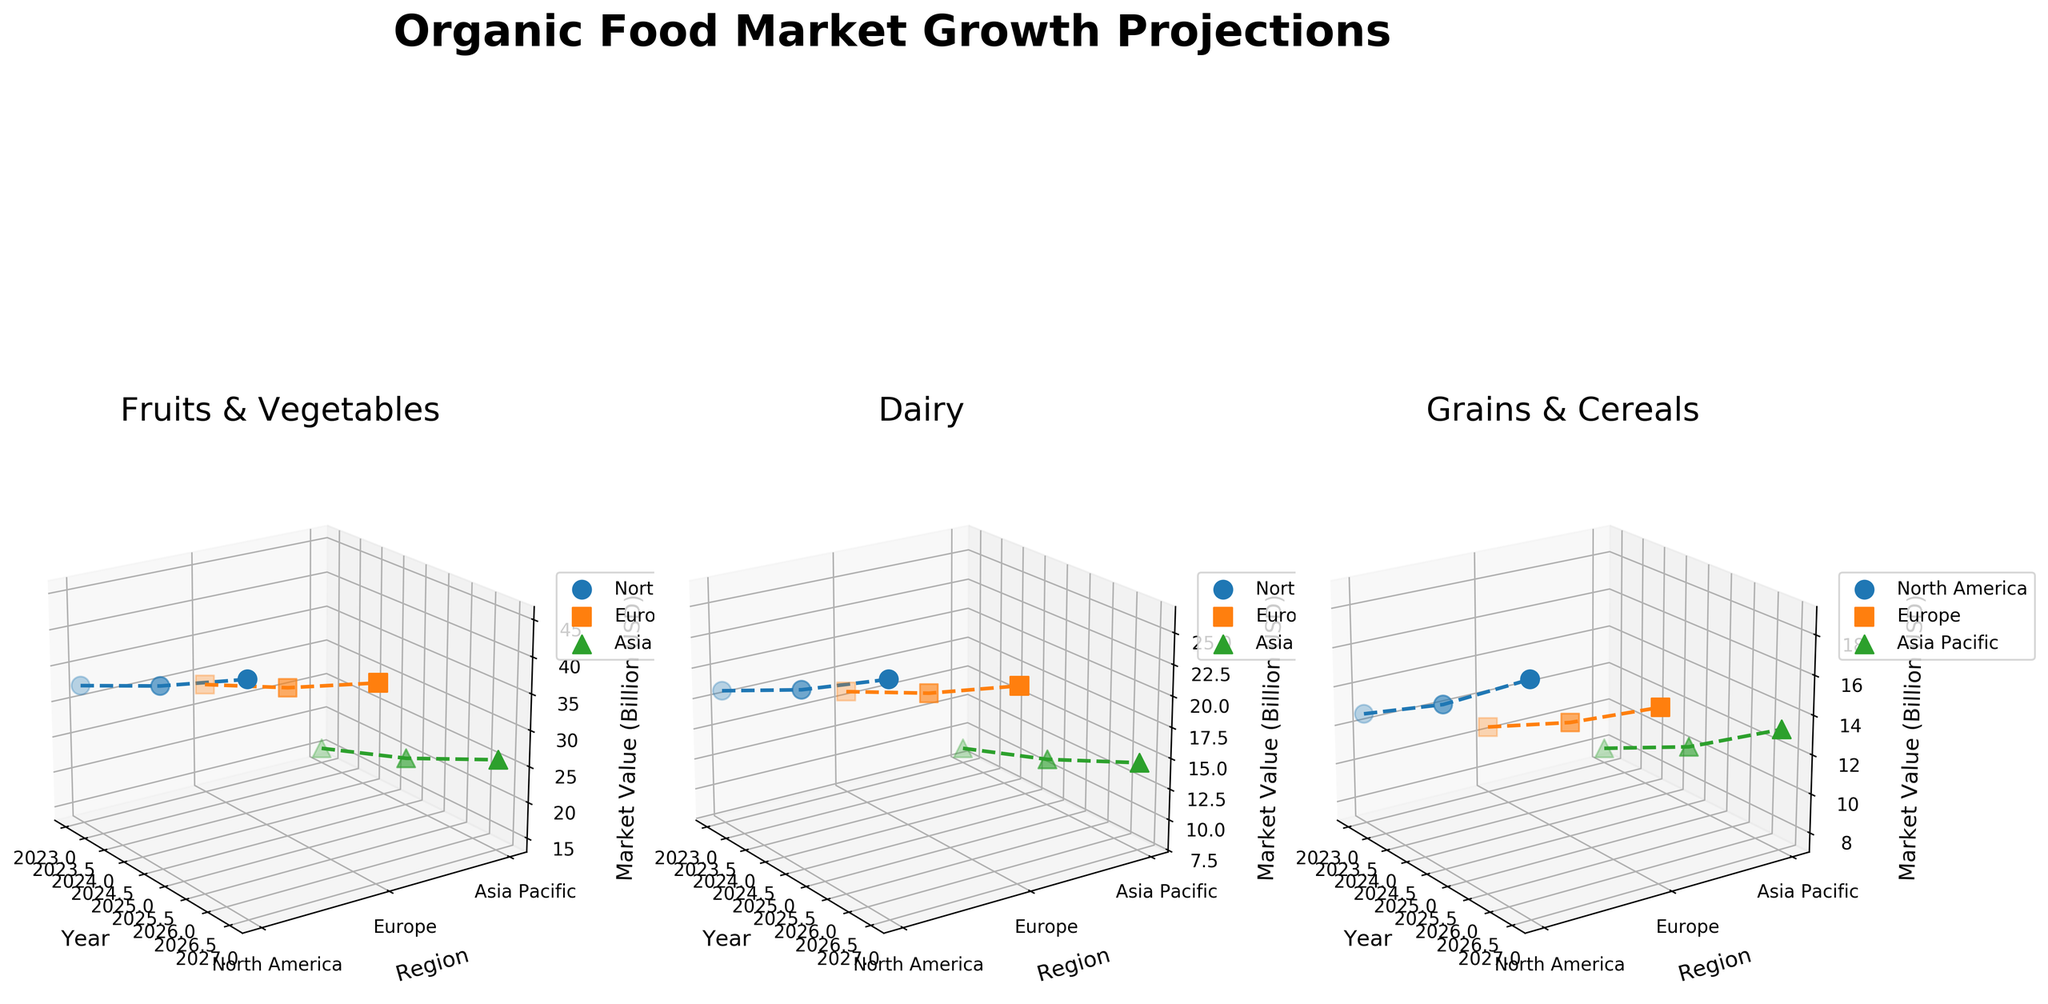What's the title of the figure? The title of the figure is located at the top center and can be directly read.
Answer: Organic Food Market Growth Projections How many regions are represented in the figure? The figure has three subplots, each plotting data for regions. The regions are distinguished by color and marker style. Each subplot has three different colors and markers, indicating three regions.
Answer: 3 Which category has the highest market value in North America in 2027? Look at the subplot for each category and identify the highest point on the market value axis (z-axis) for North America in 2027.
Answer: Fruits & Vegetables What is the trend of the market value for Dairy in Europe from 2023 to 2027? Locate the subplot for Dairy and examine the plotted lines for Europe (orange squares). From 2023 to 2027, observe the change in the market value along the z-axis.
Answer: Increasing Compare the market value of Grains & Cereals in Asia Pacific between 2023 and 2025. How much did it increase? In the subplot for Grains & Cereals, identify the z-axis values for Asia Pacific (green triangles) for the years 2023 and 2025. Calculate the difference between these values.
Answer: 2.3 Billion USD Which region shows the fastest growth in market value for Fruits & Vegetables from 2023 to 2027? In the subplot for Fruits & Vegetables, compare the slopes of the lines for North America (blue circles), Europe (orange squares), and Asia Pacific (green triangles) from 2023 to 2027. The steepest slope indicates the fastest growth.
Answer: North America What is the average market value of Dairy in Asia Pacific over the years 2023, 2025, and 2027? Gather the market values for Dairy in Asia Pacific for 2023, 2025, and 2027 and calculate the average by summing the values and dividing by 3.
Answer: 11.43 Billion USD Which category consistently shows lower market values across all regions and years? Compare the subplots for each category and observe the z-axis ranges. Identify the category with consistently lower z-axis values across all regions and years.
Answer: Grains & Cereals Between North America and Europe, which region had a higher market value for Fruits & Vegetables in 2025? In the Fruits & Vegetables subplot, compare the z-axis values for North America (blue circles) and Europe (orange squares) in the year 2025.
Answer: North America By how much did the market value for Fruits & Vegetables in Europe increase from 2023 to 2027? In the Fruits & Vegetables subplot, locate the z-axis values for Europe (orange squares) in 2023 and 2027. Subtract the 2023 value from the 2027 value.
Answer: 11.5 Billion USD 